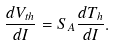<formula> <loc_0><loc_0><loc_500><loc_500>\frac { d V _ { t h } } { d I } = S _ { A } \frac { d T _ { h } } { d I } .</formula> 